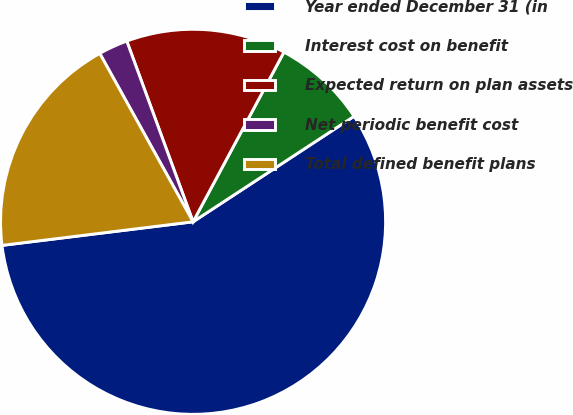Convert chart to OTSL. <chart><loc_0><loc_0><loc_500><loc_500><pie_chart><fcel>Year ended December 31 (in<fcel>Interest cost on benefit<fcel>Expected return on plan assets<fcel>Net periodic benefit cost<fcel>Total defined benefit plans<nl><fcel>57.28%<fcel>7.94%<fcel>13.42%<fcel>2.46%<fcel>18.9%<nl></chart> 